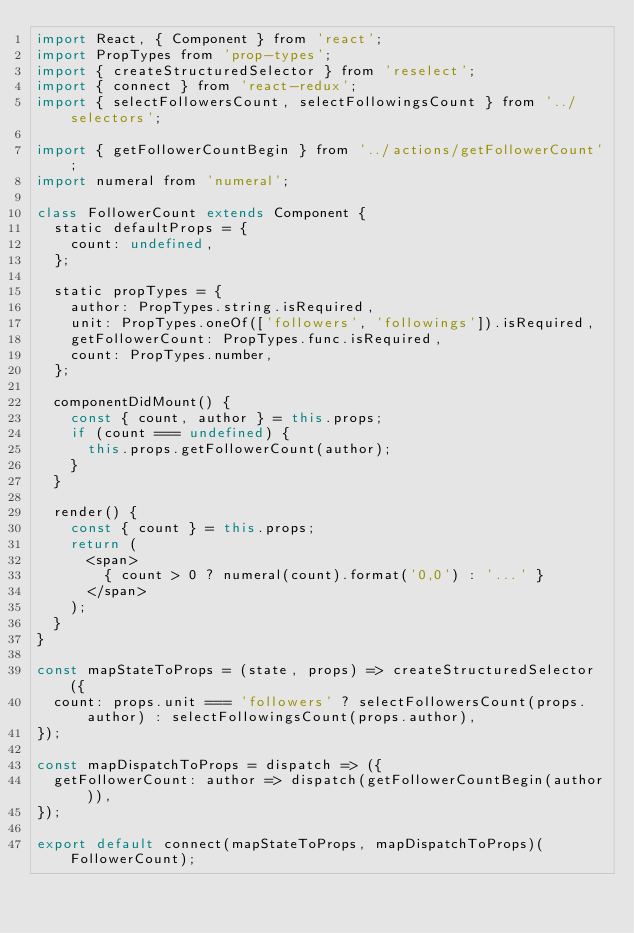Convert code to text. <code><loc_0><loc_0><loc_500><loc_500><_JavaScript_>import React, { Component } from 'react';
import PropTypes from 'prop-types';
import { createStructuredSelector } from 'reselect';
import { connect } from 'react-redux';
import { selectFollowersCount, selectFollowingsCount } from '../selectors';

import { getFollowerCountBegin } from '../actions/getFollowerCount';
import numeral from 'numeral';

class FollowerCount extends Component {
  static defaultProps = {
    count: undefined,
  };

  static propTypes = {
    author: PropTypes.string.isRequired,
    unit: PropTypes.oneOf(['followers', 'followings']).isRequired,
    getFollowerCount: PropTypes.func.isRequired,
    count: PropTypes.number,
  };

  componentDidMount() {
    const { count, author } = this.props;
    if (count === undefined) {
      this.props.getFollowerCount(author);
    }
  }

  render() {
    const { count } = this.props;
    return (
      <span>
        { count > 0 ? numeral(count).format('0,0') : '...' }
      </span>
    );
  }
}

const mapStateToProps = (state, props) => createStructuredSelector({
  count: props.unit === 'followers' ? selectFollowersCount(props.author) : selectFollowingsCount(props.author),
});

const mapDispatchToProps = dispatch => ({
  getFollowerCount: author => dispatch(getFollowerCountBegin(author)),
});

export default connect(mapStateToProps, mapDispatchToProps)(FollowerCount);
</code> 